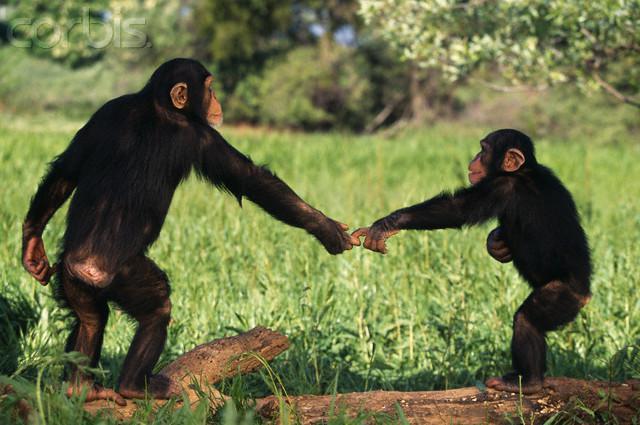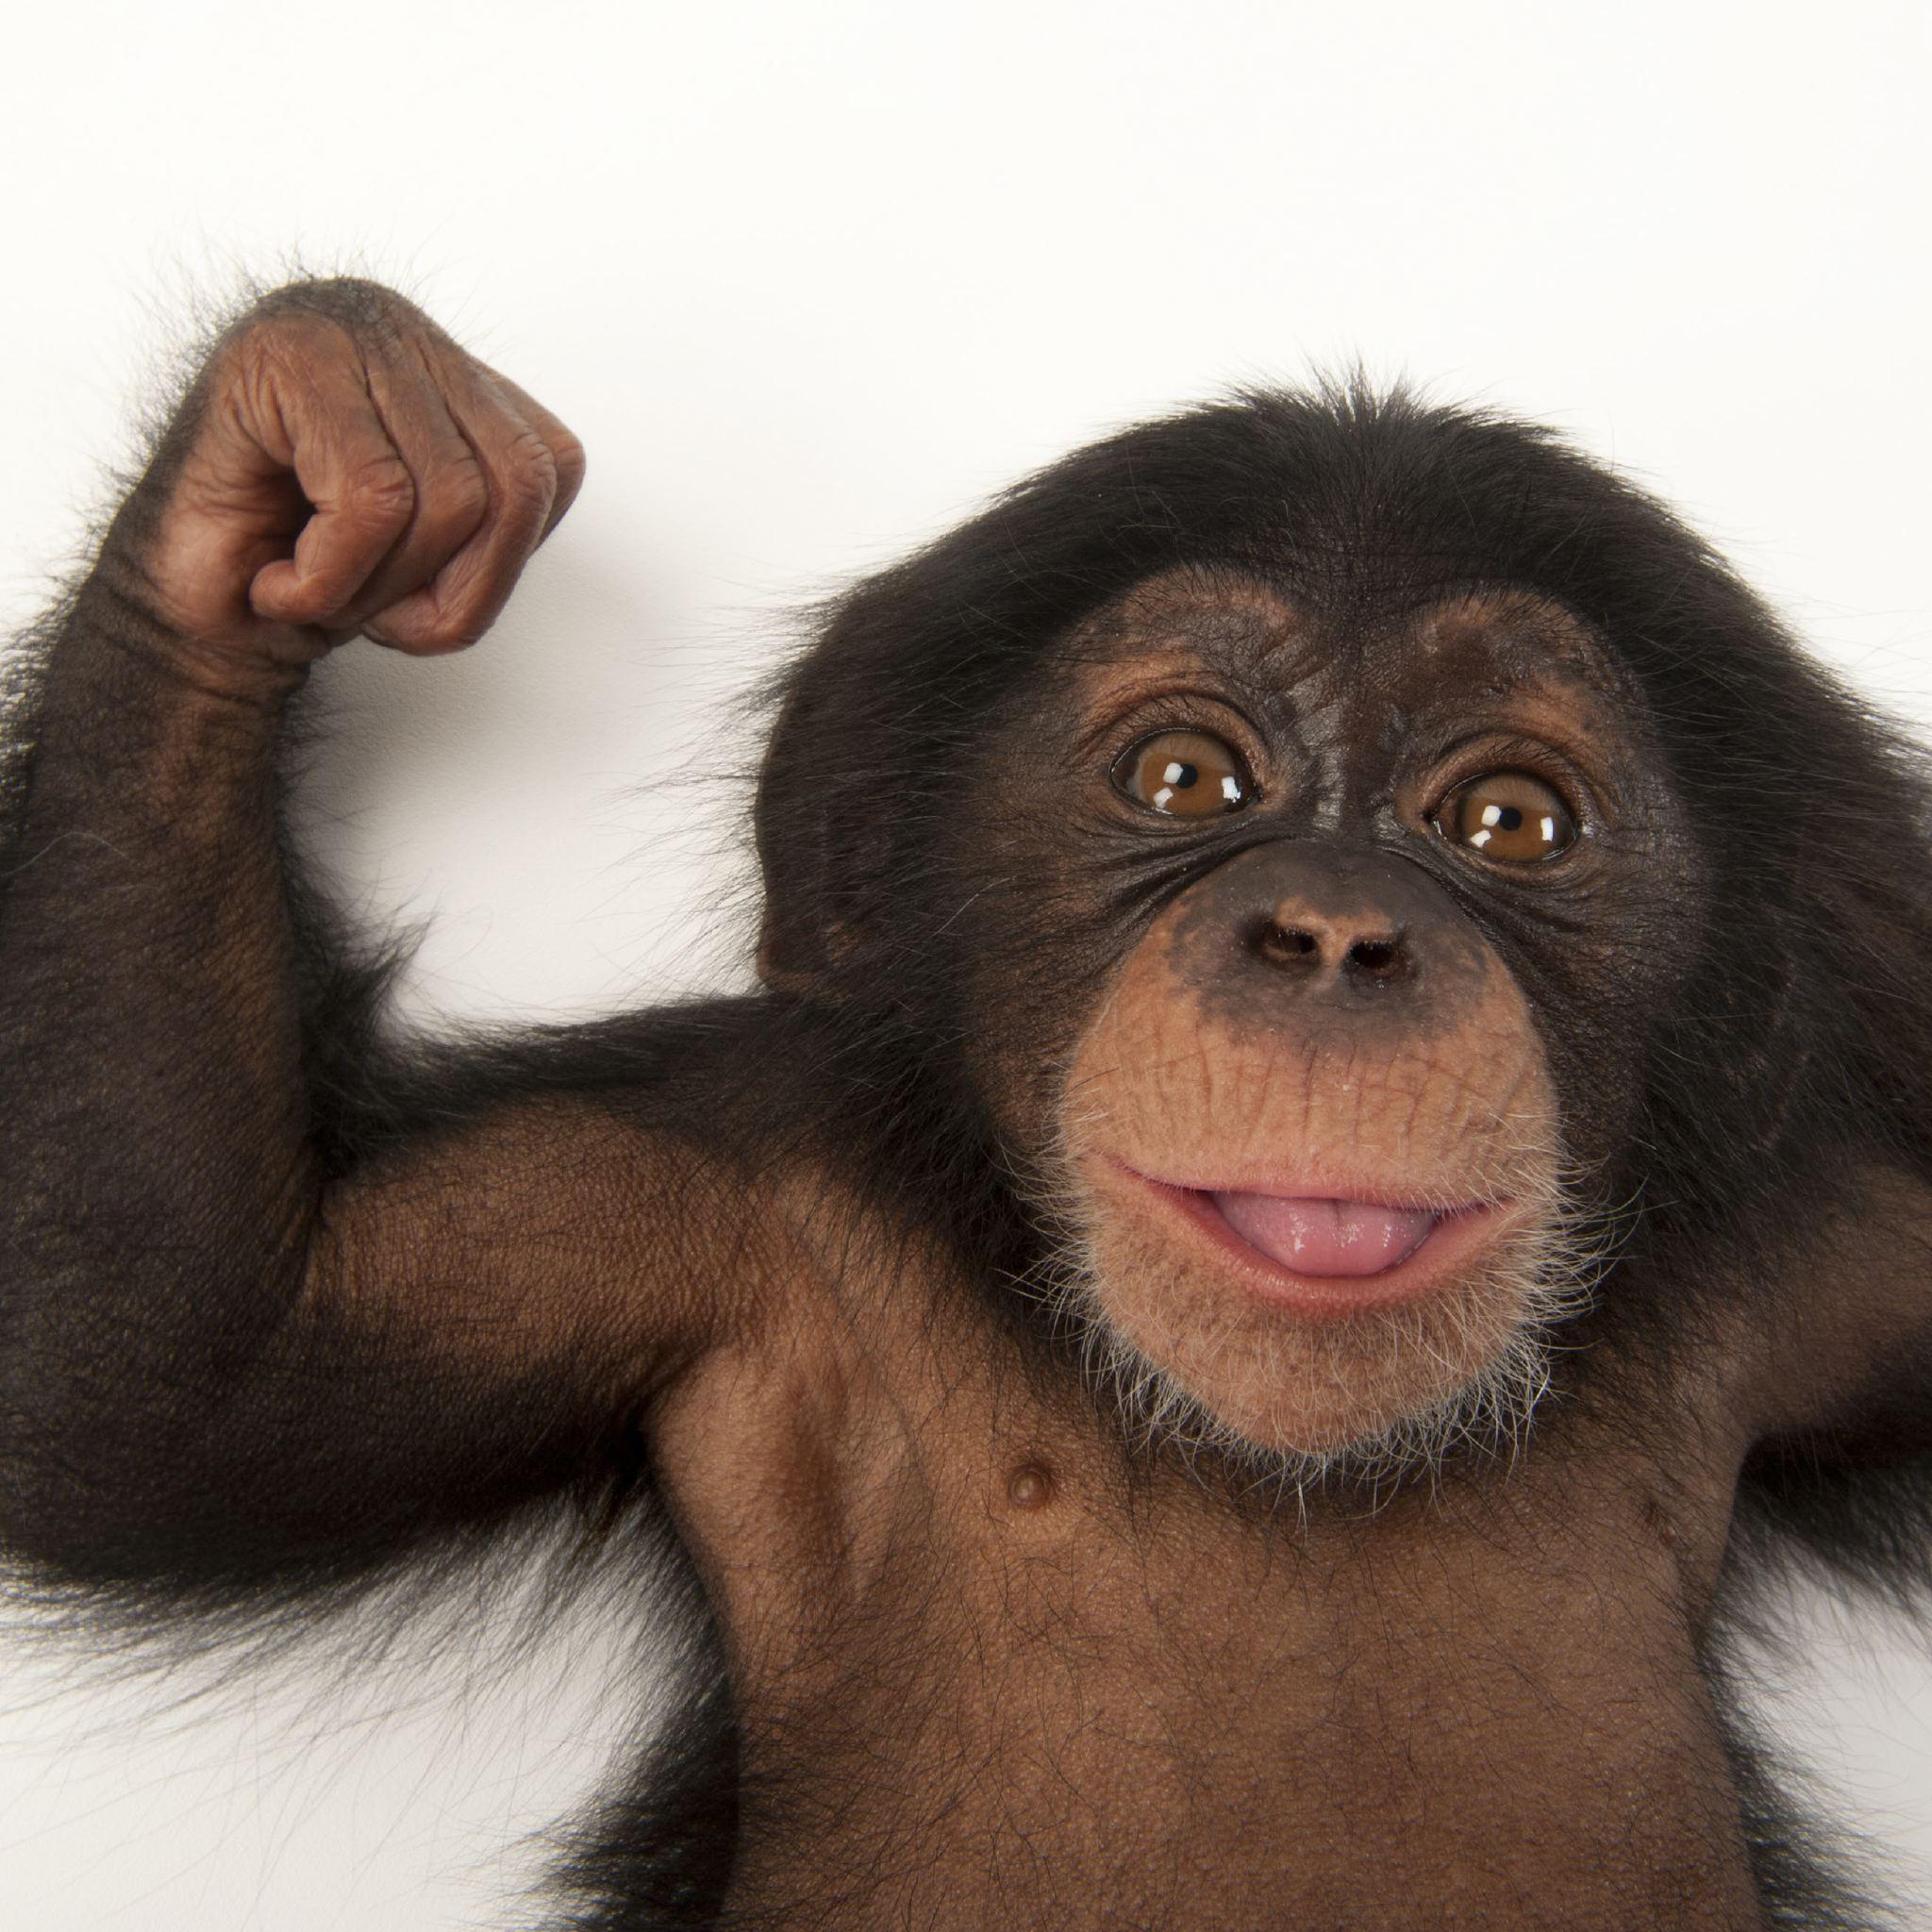The first image is the image on the left, the second image is the image on the right. Evaluate the accuracy of this statement regarding the images: "Two chimps of the same approximate size and age are present in the right image.". Is it true? Answer yes or no. No. The first image is the image on the left, the second image is the image on the right. Assess this claim about the two images: "There is exactly one monkey in the image on the left.". Correct or not? Answer yes or no. No. 